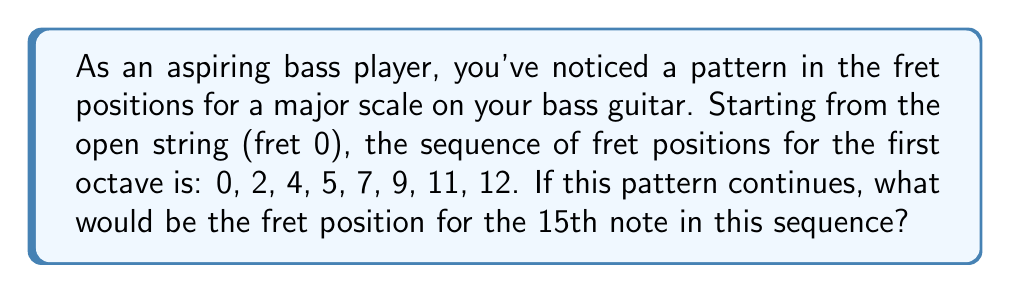What is the answer to this math problem? Let's approach this step-by-step:

1) First, let's identify the pattern in the given sequence:
   0, 2, 4, 5, 7, 9, 11, 12

2) We can see that the differences between consecutive numbers are:
   2, 2, 1, 2, 2, 2, 1

3) This pattern represents the whole and half steps in a major scale:
   W, W, H, W, W, W, H (where W = whole step, H = half step)

4) We can see that this pattern repeats after the 8th note (12th fret), which completes one octave.

5) To find the 15th note, we need to continue this pattern for 7 more notes:

   12 (8th note)
   14 (9th note, +2)
   16 (10th note, +2)
   17 (11th note, +1)
   19 (12th note, +2)
   21 (13th note, +2)
   23 (14th note, +2)
   24 (15th note, +1)

6) Therefore, the 15th note in the sequence would be on the 24th fret.

7) We can also express this mathematically:
   $$24 = 12 + 12 = 12 \times 2$$
   This shows that the 15th note is exactly two octaves above the open string.
Answer: 24 